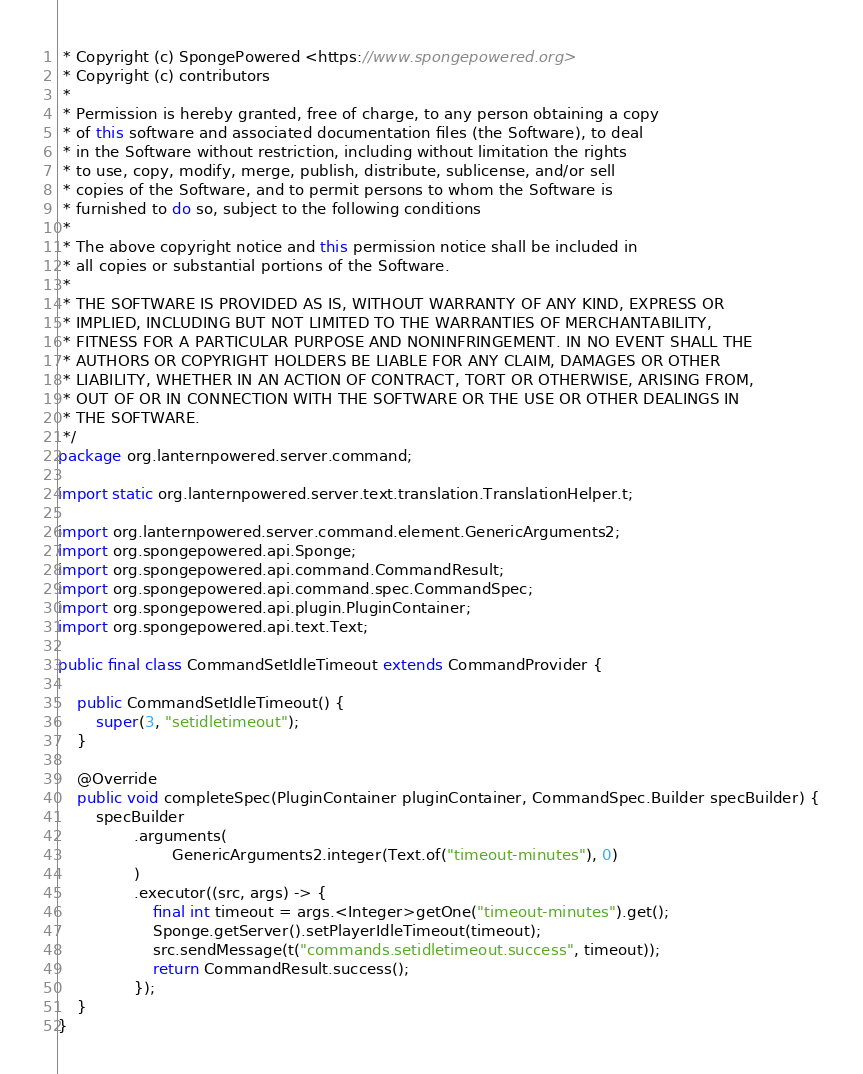<code> <loc_0><loc_0><loc_500><loc_500><_Java_> * Copyright (c) SpongePowered <https://www.spongepowered.org>
 * Copyright (c) contributors
 *
 * Permission is hereby granted, free of charge, to any person obtaining a copy
 * of this software and associated documentation files (the Software), to deal
 * in the Software without restriction, including without limitation the rights
 * to use, copy, modify, merge, publish, distribute, sublicense, and/or sell
 * copies of the Software, and to permit persons to whom the Software is
 * furnished to do so, subject to the following conditions
 *
 * The above copyright notice and this permission notice shall be included in
 * all copies or substantial portions of the Software.
 *
 * THE SOFTWARE IS PROVIDED AS IS, WITHOUT WARRANTY OF ANY KIND, EXPRESS OR
 * IMPLIED, INCLUDING BUT NOT LIMITED TO THE WARRANTIES OF MERCHANTABILITY,
 * FITNESS FOR A PARTICULAR PURPOSE AND NONINFRINGEMENT. IN NO EVENT SHALL THE
 * AUTHORS OR COPYRIGHT HOLDERS BE LIABLE FOR ANY CLAIM, DAMAGES OR OTHER
 * LIABILITY, WHETHER IN AN ACTION OF CONTRACT, TORT OR OTHERWISE, ARISING FROM,
 * OUT OF OR IN CONNECTION WITH THE SOFTWARE OR THE USE OR OTHER DEALINGS IN
 * THE SOFTWARE.
 */
package org.lanternpowered.server.command;

import static org.lanternpowered.server.text.translation.TranslationHelper.t;

import org.lanternpowered.server.command.element.GenericArguments2;
import org.spongepowered.api.Sponge;
import org.spongepowered.api.command.CommandResult;
import org.spongepowered.api.command.spec.CommandSpec;
import org.spongepowered.api.plugin.PluginContainer;
import org.spongepowered.api.text.Text;

public final class CommandSetIdleTimeout extends CommandProvider {

    public CommandSetIdleTimeout() {
        super(3, "setidletimeout");
    }

    @Override
    public void completeSpec(PluginContainer pluginContainer, CommandSpec.Builder specBuilder) {
        specBuilder
                .arguments(
                        GenericArguments2.integer(Text.of("timeout-minutes"), 0)
                )
                .executor((src, args) -> {
                    final int timeout = args.<Integer>getOne("timeout-minutes").get();
                    Sponge.getServer().setPlayerIdleTimeout(timeout);
                    src.sendMessage(t("commands.setidletimeout.success", timeout));
                    return CommandResult.success();
                });
    }
}
</code> 